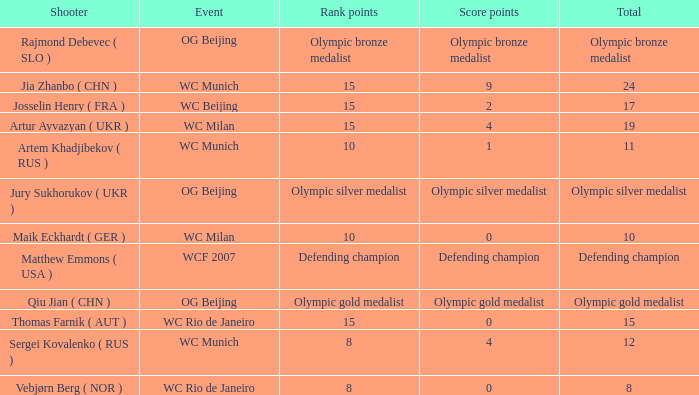Who was the shooter for the WC Beijing event? Josselin Henry ( FRA ). 